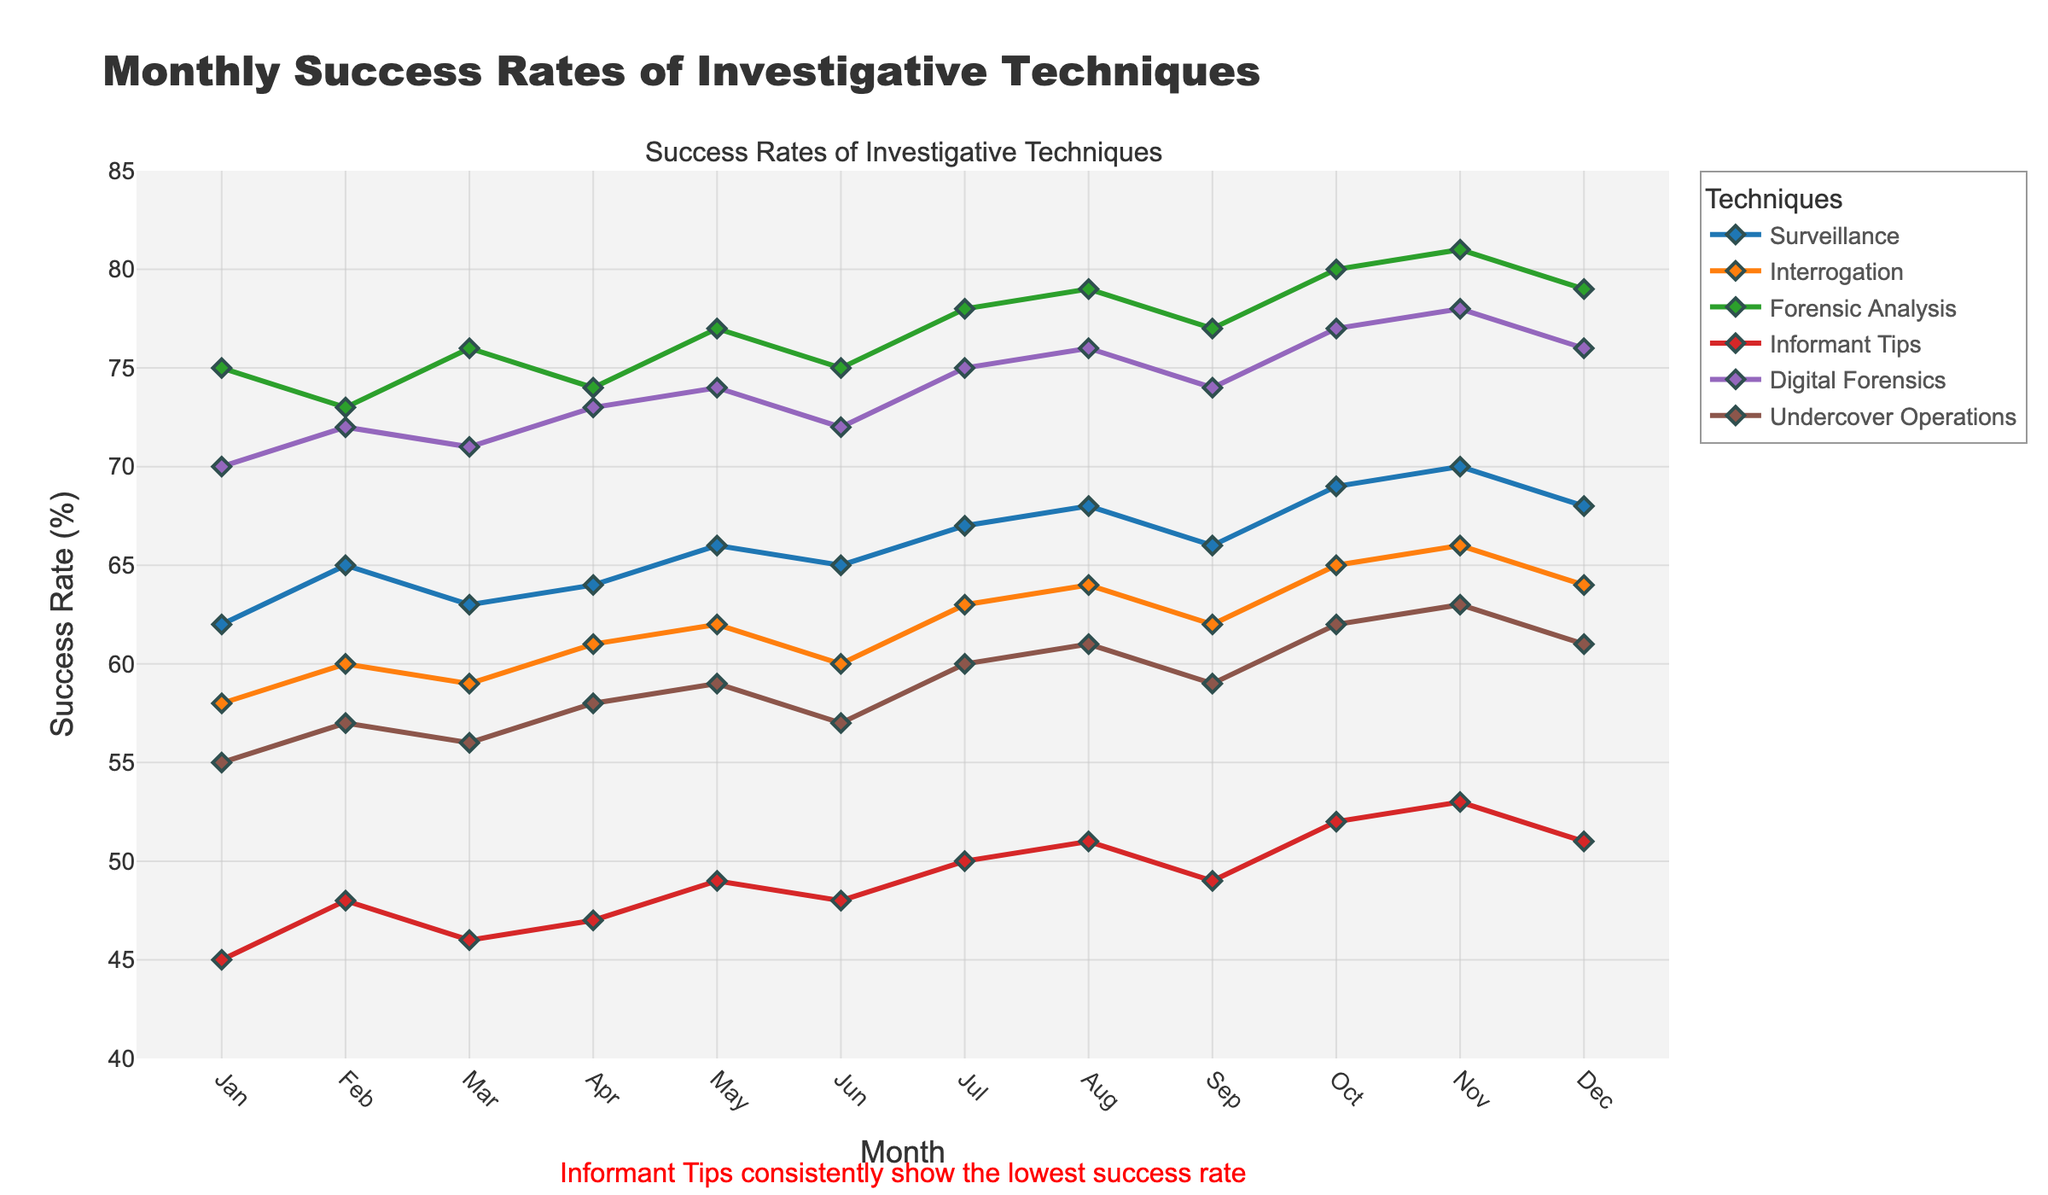Which investigative technique has the highest success rate in December? To find the investigative technique with the highest success rate in December, we look at the data points for December and identify the maximum value. Forensic Analysis has a success rate of 79%, which is the highest.
Answer: Forensic Analysis Which technique showed the largest increase in success rate from January to December? To determine which technique had the largest increase from January to December, we calculate the difference between the success rates of December and January for each technique: Surveillance (68-62), Interrogation (64-58), Forensic Analysis (79-75), Informant Tips (51-45), Digital Forensics (76-70), Undercover Operations (61-55). Interrogation showed the largest increase, with an increase of 6%.
Answer: Interrogation What is the average success rate of Digital Forensics over the year? To calculate the average success rate of Digital Forensics, we sum the monthly success rates and divide by the number of months: (70 + 72 + 71 + 73 + 74 + 72 + 75 + 76 + 74 + 77 + 78 + 76) / 12 = 73.08.
Answer: 73.08% Which month had the highest overall success rate for Informant Tips? Reviewing the monthly data points for Informant Tips, the highest value is in November with a 53% success rate.
Answer: November What is the cumulative success rate of Surveillance from January to March? To find the cumulative success rate for Surveillance from January to March, sum the success rates for these months: 62 + 65 + 63 = 190.
Answer: 190% Which month showed the largest difference in success rates between Surveillance and Informant Tips? To find the month with the largest difference, calculate the absolute differences for each month and find the maximum: Jan (62-45=17), Feb (65-48=17), Mar (63-46=17), Apr (64-47=17), May (66-49=17), Jun (65-48=17), Jul (67-50=17), Aug (68-51=17), Sep (66-49=17), Oct (69-52=17), Nov (70-53=17), Dec (68-51=17). All differences are 17, so all months have the same difference.
Answer: Any month (17%) How does the success rate trend for Undercover Operations change throughout the year? From the visual graph, we observe that the success rate of Undercover Operations steadily increases from 55% in January to 63% in November and then has a slight decrease to 61% in December.
Answer: Increases then decreases 